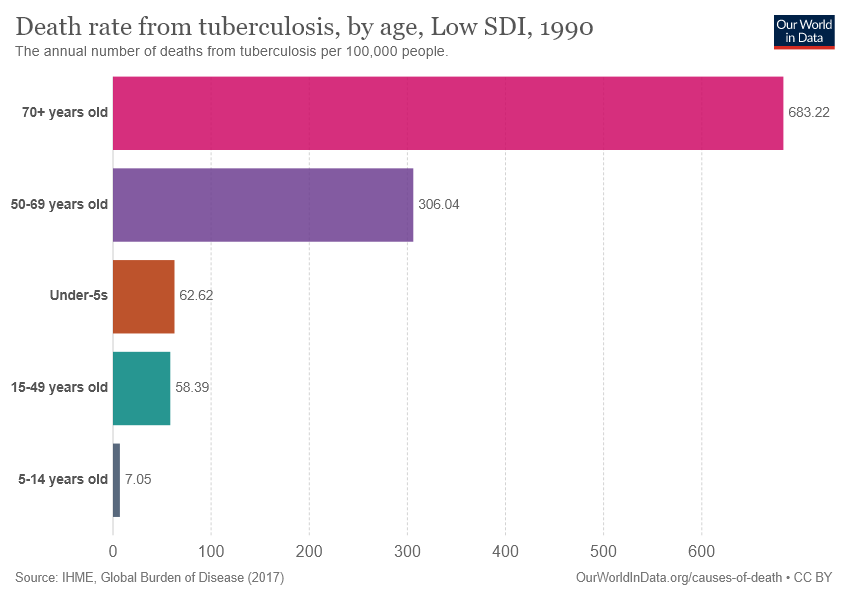Mention a couple of crucial points in this snapshot. The value of the largest bar is 683.22. The value of the largest bar is 676.17, while the value of the smallest bar is 676.17 